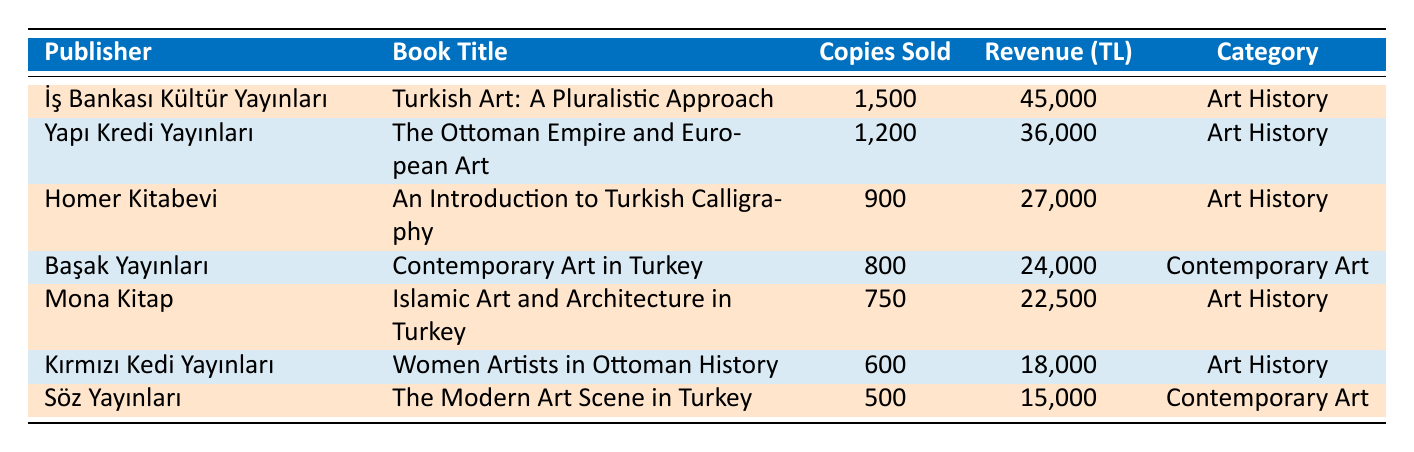What is the total number of copies sold for all publishers? To find the total copies sold, we need to add the copies sold from all publishers. The sum is 1500 + 1200 + 900 + 800 + 750 + 600 + 500 = 4550.
Answer: 4550 Which book by İş Bankası Kültür Yayınları sold the most copies? The book "Turkish Art: A Pluralistic Approach" by İş Bankası Kültür Yayınları sold the most copies, totaling 1500.
Answer: Turkish Art: A Pluralistic Approach What percentage of total revenue does Yapı Kredi Yayınları contribute? First, we find Yapı Kredi Yayınları' revenue, which is 36000. Then, we calculate total revenue as 45000 + 36000 + 27000 + 24000 + 22500 + 18000 + 15000 = 187500. The percentage can be calculated as (36000 / 187500) * 100 = 19.2%.
Answer: 19.2% Did Kırmızı Kedi Yayınları generate more revenue than Homer Kitabevi? Kırmızı Kedi Yayınları generated 18000, and Homer Kitabevi generated 27000. Since 18000 is less than 27000, the statement is false.
Answer: No What is the average number of copies sold for books in the Art History category? The copies sold in Art History are 1500, 1200, 900, 750, and 600. Summing them gives 1500 + 1200 + 900 + 750 + 600 = 3950. There are 5 books in this category, so the average is 3950 / 5 = 790.
Answer: 790 Which publisher has the highest revenue and what is that revenue? By examining the revenue column, İş Bankası Kültür Yayınları has the highest revenue of 45000.
Answer: İş Bankası Kültür Yayınları, 45000 What is the difference in copies sold between the best-selling and the lowest-selling book? The best-selling book is "Turkish Art: A Pluralistic Approach" with 1500 copies sold, and the lowest-selling is "The Modern Art Scene in Turkey" with 500. The difference is 1500 - 500 = 1000.
Answer: 1000 